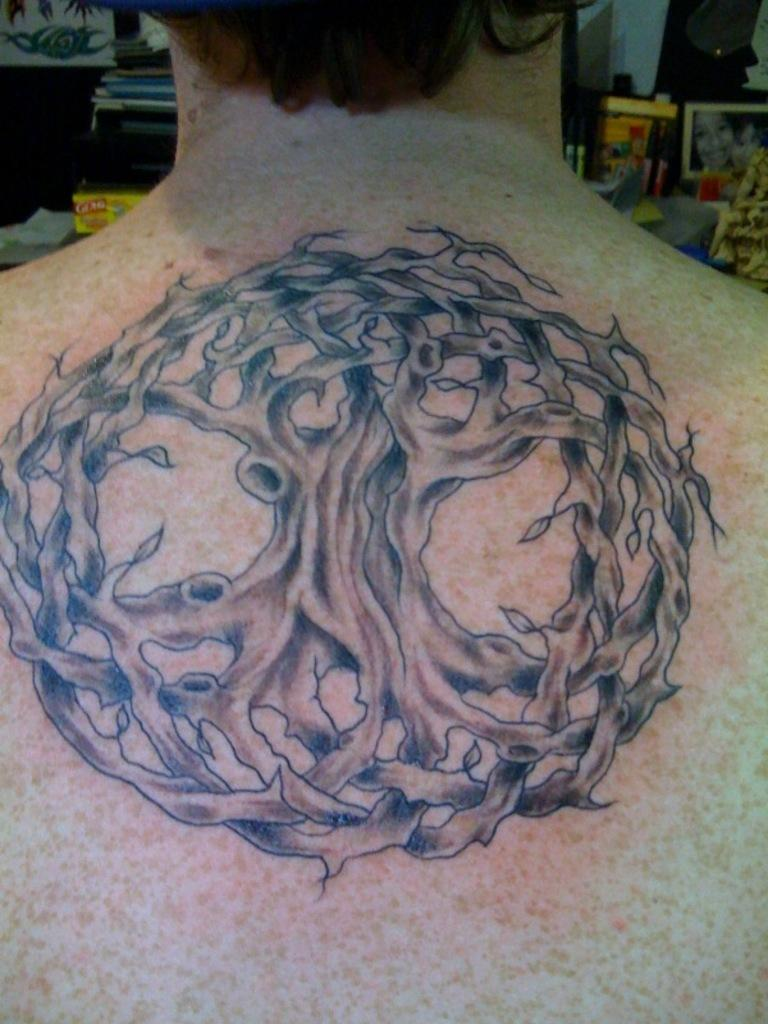What can be observed about the person in the image? There is a person with a tattoo in the image. What is visible in the background of the image? There is a photo and other objects in the background of the image. What type of dress is the girl wearing in the image? There is no girl present in the image, and no dress is mentioned in the provided facts. 